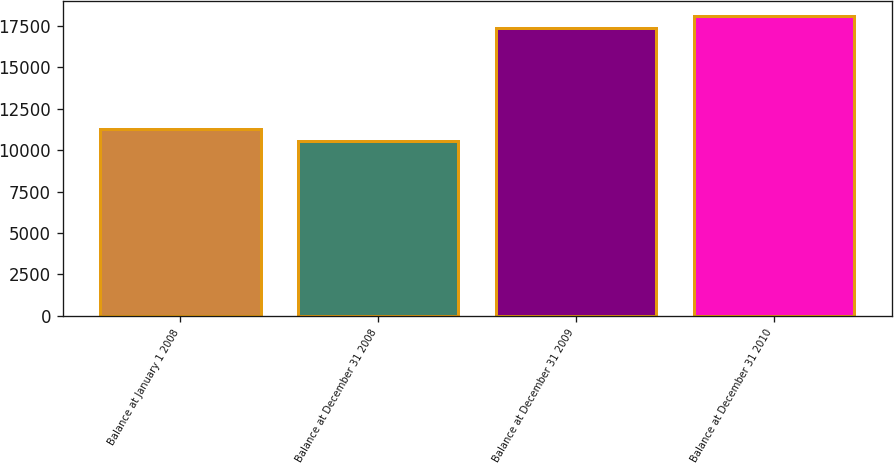Convert chart to OTSL. <chart><loc_0><loc_0><loc_500><loc_500><bar_chart><fcel>Balance at January 1 2008<fcel>Balance at December 31 2008<fcel>Balance at December 31 2009<fcel>Balance at December 31 2010<nl><fcel>11254.8<fcel>10566<fcel>17364<fcel>18052.8<nl></chart> 